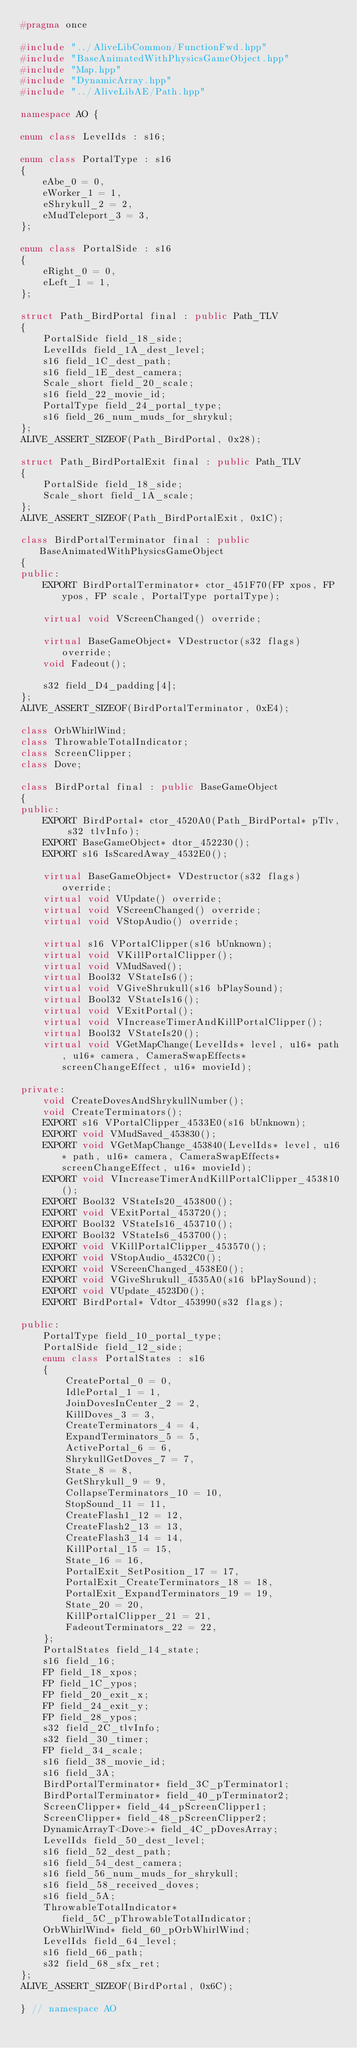Convert code to text. <code><loc_0><loc_0><loc_500><loc_500><_C++_>#pragma once

#include "../AliveLibCommon/FunctionFwd.hpp"
#include "BaseAnimatedWithPhysicsGameObject.hpp"
#include "Map.hpp"
#include "DynamicArray.hpp"
#include "../AliveLibAE/Path.hpp"

namespace AO {

enum class LevelIds : s16;

enum class PortalType : s16
{
    eAbe_0 = 0,
    eWorker_1 = 1,
    eShrykull_2 = 2,
    eMudTeleport_3 = 3,
};

enum class PortalSide : s16
{
    eRight_0 = 0,
    eLeft_1 = 1,
};

struct Path_BirdPortal final : public Path_TLV
{
    PortalSide field_18_side;
    LevelIds field_1A_dest_level;
    s16 field_1C_dest_path;
    s16 field_1E_dest_camera;
    Scale_short field_20_scale;
    s16 field_22_movie_id;
    PortalType field_24_portal_type;
    s16 field_26_num_muds_for_shrykul;
};
ALIVE_ASSERT_SIZEOF(Path_BirdPortal, 0x28);

struct Path_BirdPortalExit final : public Path_TLV
{
    PortalSide field_18_side;
    Scale_short field_1A_scale;
};
ALIVE_ASSERT_SIZEOF(Path_BirdPortalExit, 0x1C);

class BirdPortalTerminator final : public BaseAnimatedWithPhysicsGameObject
{
public:
    EXPORT BirdPortalTerminator* ctor_451F70(FP xpos, FP ypos, FP scale, PortalType portalType);

    virtual void VScreenChanged() override;

    virtual BaseGameObject* VDestructor(s32 flags) override;
    void Fadeout();

    s32 field_D4_padding[4];
};
ALIVE_ASSERT_SIZEOF(BirdPortalTerminator, 0xE4);

class OrbWhirlWind;
class ThrowableTotalIndicator;
class ScreenClipper;
class Dove;

class BirdPortal final : public BaseGameObject
{
public:
    EXPORT BirdPortal* ctor_4520A0(Path_BirdPortal* pTlv, s32 tlvInfo);
    EXPORT BaseGameObject* dtor_452230();
    EXPORT s16 IsScaredAway_4532E0();

    virtual BaseGameObject* VDestructor(s32 flags) override;
    virtual void VUpdate() override;
    virtual void VScreenChanged() override;
    virtual void VStopAudio() override;

    virtual s16 VPortalClipper(s16 bUnknown);
    virtual void VKillPortalClipper();
    virtual void VMudSaved();
    virtual Bool32 VStateIs6();
    virtual void VGiveShrukull(s16 bPlaySound);
    virtual Bool32 VStateIs16();
    virtual void VExitPortal();
    virtual void VIncreaseTimerAndKillPortalClipper();
    virtual Bool32 VStateIs20();
    virtual void VGetMapChange(LevelIds* level, u16* path, u16* camera, CameraSwapEffects* screenChangeEffect, u16* movieId);

private:
    void CreateDovesAndShrykullNumber();
    void CreateTerminators();
    EXPORT s16 VPortalClipper_4533E0(s16 bUnknown);
    EXPORT void VMudSaved_453830();
    EXPORT void VGetMapChange_453840(LevelIds* level, u16* path, u16* camera, CameraSwapEffects* screenChangeEffect, u16* movieId);
    EXPORT void VIncreaseTimerAndKillPortalClipper_453810();
    EXPORT Bool32 VStateIs20_453800();
    EXPORT void VExitPortal_453720();
    EXPORT Bool32 VStateIs16_453710();
    EXPORT Bool32 VStateIs6_453700();
    EXPORT void VKillPortalClipper_453570();
    EXPORT void VStopAudio_4532C0();
    EXPORT void VScreenChanged_4538E0();
    EXPORT void VGiveShrukull_4535A0(s16 bPlaySound);
    EXPORT void VUpdate_4523D0();
    EXPORT BirdPortal* Vdtor_453990(s32 flags);

public:
    PortalType field_10_portal_type;
    PortalSide field_12_side;
    enum class PortalStates : s16
    {
        CreatePortal_0 = 0,
        IdlePortal_1 = 1,
        JoinDovesInCenter_2 = 2,
        KillDoves_3 = 3,
        CreateTerminators_4 = 4,
        ExpandTerminators_5 = 5,
        ActivePortal_6 = 6,
        ShrykullGetDoves_7 = 7,
        State_8 = 8,
        GetShrykull_9 = 9,
        CollapseTerminators_10 = 10,
        StopSound_11 = 11,
        CreateFlash1_12 = 12,
        CreateFlash2_13 = 13,
        CreateFlash3_14 = 14,
        KillPortal_15 = 15,
        State_16 = 16,
        PortalExit_SetPosition_17 = 17,
        PortalExit_CreateTerminators_18 = 18,
        PortalExit_ExpandTerminators_19 = 19,
        State_20 = 20,
        KillPortalClipper_21 = 21,
        FadeoutTerminators_22 = 22,
    };
    PortalStates field_14_state;
    s16 field_16;
    FP field_18_xpos;
    FP field_1C_ypos;
    FP field_20_exit_x;
    FP field_24_exit_y;
    FP field_28_ypos;
    s32 field_2C_tlvInfo;
    s32 field_30_timer;
    FP field_34_scale;
    s16 field_38_movie_id;
    s16 field_3A;
    BirdPortalTerminator* field_3C_pTerminator1;
    BirdPortalTerminator* field_40_pTerminator2;
    ScreenClipper* field_44_pScreenClipper1;
    ScreenClipper* field_48_pScreenClipper2;
    DynamicArrayT<Dove>* field_4C_pDovesArray;
    LevelIds field_50_dest_level;
    s16 field_52_dest_path;
    s16 field_54_dest_camera;
    s16 field_56_num_muds_for_shrykull;
    s16 field_58_received_doves;
    s16 field_5A;
    ThrowableTotalIndicator* field_5C_pThrowableTotalIndicator;
    OrbWhirlWind* field_60_pOrbWhirlWind;
    LevelIds field_64_level;
    s16 field_66_path;
    s32 field_68_sfx_ret;
};
ALIVE_ASSERT_SIZEOF(BirdPortal, 0x6C);

} // namespace AO
</code> 